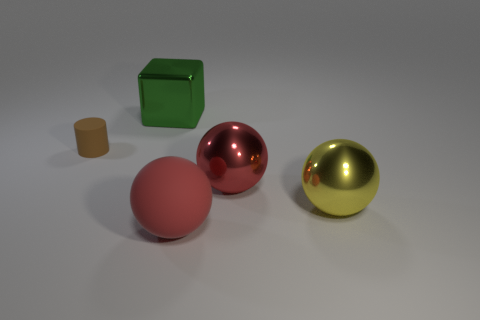Could you describe the shapes and colors of the objects in the image? Certainly! The image includes a matte pink cylinder, a shiny red sphere, a shiny golden-yellow sphere, and a reflective green cube. 